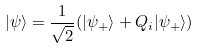<formula> <loc_0><loc_0><loc_500><loc_500>| \psi \rangle = \frac { 1 } { \sqrt { 2 } } ( | \psi _ { + } \rangle + Q _ { i } | \psi _ { + } \rangle )</formula> 